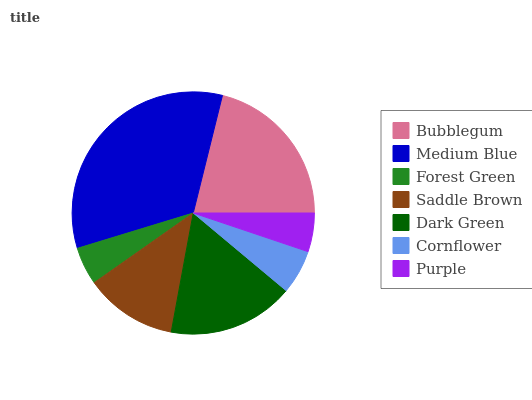Is Forest Green the minimum?
Answer yes or no. Yes. Is Medium Blue the maximum?
Answer yes or no. Yes. Is Medium Blue the minimum?
Answer yes or no. No. Is Forest Green the maximum?
Answer yes or no. No. Is Medium Blue greater than Forest Green?
Answer yes or no. Yes. Is Forest Green less than Medium Blue?
Answer yes or no. Yes. Is Forest Green greater than Medium Blue?
Answer yes or no. No. Is Medium Blue less than Forest Green?
Answer yes or no. No. Is Saddle Brown the high median?
Answer yes or no. Yes. Is Saddle Brown the low median?
Answer yes or no. Yes. Is Medium Blue the high median?
Answer yes or no. No. Is Forest Green the low median?
Answer yes or no. No. 